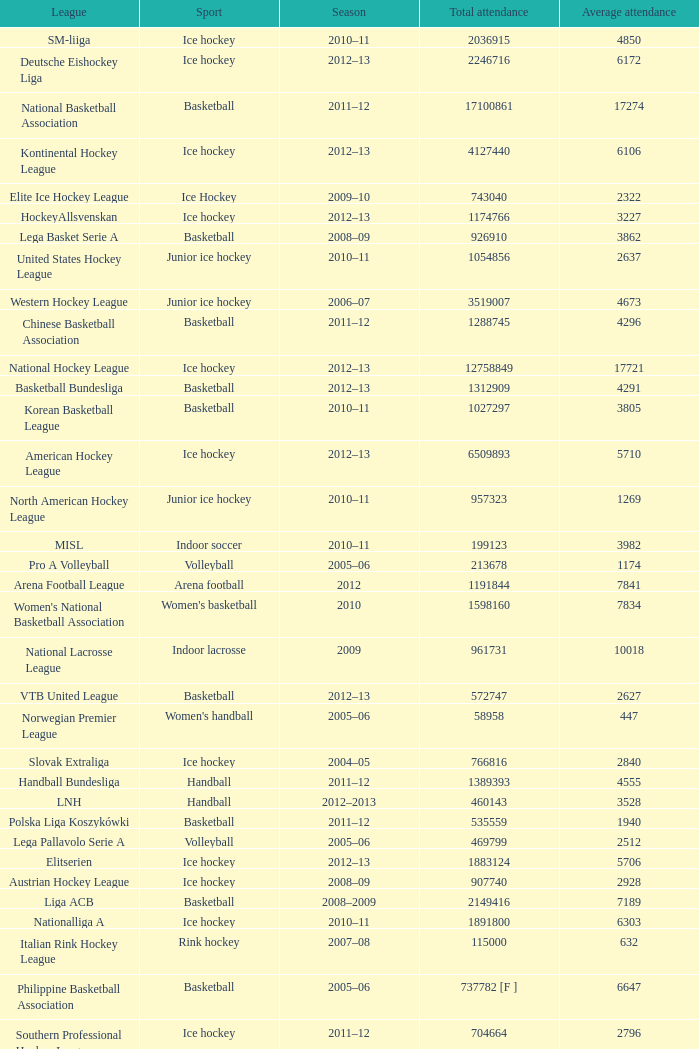Could you help me parse every detail presented in this table? {'header': ['League', 'Sport', 'Season', 'Total attendance', 'Average attendance'], 'rows': [['SM-liiga', 'Ice hockey', '2010–11', '2036915', '4850'], ['Deutsche Eishockey Liga', 'Ice hockey', '2012–13', '2246716', '6172'], ['National Basketball Association', 'Basketball', '2011–12', '17100861', '17274'], ['Kontinental Hockey League', 'Ice hockey', '2012–13', '4127440', '6106'], ['Elite Ice Hockey League', 'Ice Hockey', '2009–10', '743040', '2322'], ['HockeyAllsvenskan', 'Ice hockey', '2012–13', '1174766', '3227'], ['Lega Basket Serie A', 'Basketball', '2008–09', '926910', '3862'], ['United States Hockey League', 'Junior ice hockey', '2010–11', '1054856', '2637'], ['Western Hockey League', 'Junior ice hockey', '2006–07', '3519007', '4673'], ['Chinese Basketball Association', 'Basketball', '2011–12', '1288745', '4296'], ['National Hockey League', 'Ice hockey', '2012–13', '12758849', '17721'], ['Basketball Bundesliga', 'Basketball', '2012–13', '1312909', '4291'], ['Korean Basketball League', 'Basketball', '2010–11', '1027297', '3805'], ['American Hockey League', 'Ice hockey', '2012–13', '6509893', '5710'], ['North American Hockey League', 'Junior ice hockey', '2010–11', '957323', '1269'], ['MISL', 'Indoor soccer', '2010–11', '199123', '3982'], ['Pro A Volleyball', 'Volleyball', '2005–06', '213678', '1174'], ['Arena Football League', 'Arena football', '2012', '1191844', '7841'], ["Women's National Basketball Association", "Women's basketball", '2010', '1598160', '7834'], ['National Lacrosse League', 'Indoor lacrosse', '2009', '961731', '10018'], ['VTB United League', 'Basketball', '2012–13', '572747', '2627'], ['Norwegian Premier League', "Women's handball", '2005–06', '58958', '447'], ['Slovak Extraliga', 'Ice hockey', '2004–05', '766816', '2840'], ['Handball Bundesliga', 'Handball', '2011–12', '1389393', '4555'], ['LNH', 'Handball', '2012–2013', '460143', '3528'], ['Polska Liga Koszykówki', 'Basketball', '2011–12', '535559', '1940'], ['Lega Pallavolo Serie A', 'Volleyball', '2005–06', '469799', '2512'], ['Elitserien', 'Ice hockey', '2012–13', '1883124', '5706'], ['Austrian Hockey League', 'Ice hockey', '2008–09', '907740', '2928'], ['Liga ACB', 'Basketball', '2008–2009', '2149416', '7189'], ['Nationalliga A', 'Ice hockey', '2010–11', '1891800', '6303'], ['Italian Rink Hockey League', 'Rink hockey', '2007–08', '115000', '632'], ['Philippine Basketball Association', 'Basketball', '2005–06', '737782 [F ]', '6647'], ['Southern Professional Hockey League', 'Ice hockey', '2011–12', '704664', '2796'], ['UPC Ligaen', 'Ice hockey', '2005–06', '329768', '1335'], ['Russian Basketball Super League', 'Basketball', '2010–11', '385702', '2401'], ['Ontario Hockey League', 'Junior ice hockey', '2006–07', '2670267', '3933'], ['Czech Extraliga', 'Ice hockey', '2010–11', '1796704', '4936'], ['Euroleague [G ]', 'Basketball', '2009–10', '1238980', '6590'], ['Central Hockey League', 'Ice hockey', '2011–12', '1867801', '4042'], ['National Basketball League', 'Basketball', '2012–13', '636820', '5397'], ['Minor Hockey League', 'Ice Hockey', '2012–13', '479003', '467'], ['ECHL', 'Ice hockey', '2012–13', '3917598', '4731'], ['af2', 'Arena football', '2005', '716422', '4873'], ['Major Hockey League', 'Ice Hockey', '2012–13', '1356319', '1932'], ['Quebec Major Junior Hockey League', 'Junior ice hockey', '2006–07', '2268508', '3601'], ['Oddset Ligaen', 'Ice hockey', '2007–08', '407972', '1534']]} What's the average attendance of the league with a total attendance of 2268508? 3601.0. 